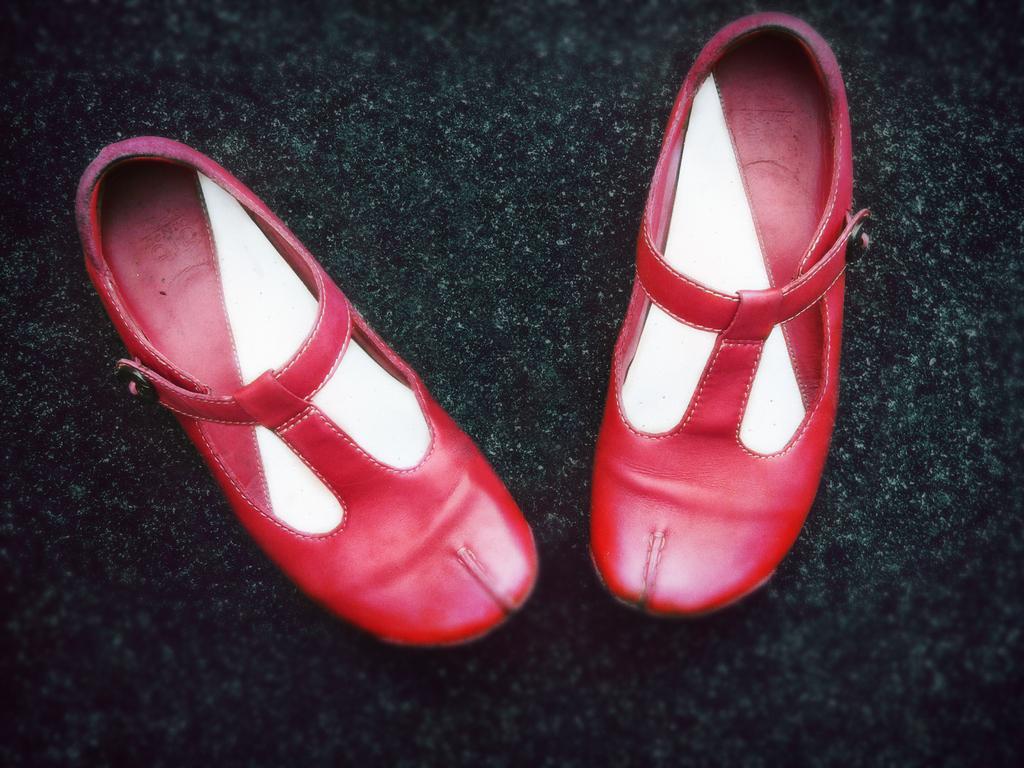Can you describe this image briefly? We can see footwear on the surface. 